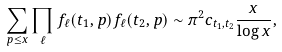<formula> <loc_0><loc_0><loc_500><loc_500>\sum _ { p \leq x } \prod _ { \ell } f _ { \ell } ( t _ { 1 } , p ) f _ { \ell } ( t _ { 2 } , p ) & \sim { \pi ^ { 2 } c _ { t _ { 1 } , t _ { 2 } } } \frac { x } { \log { x } } ,</formula> 